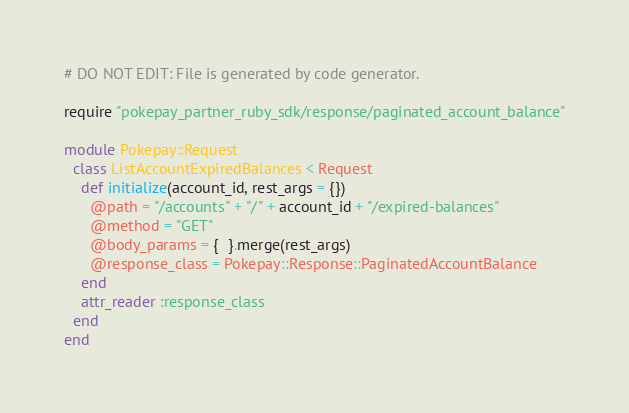<code> <loc_0><loc_0><loc_500><loc_500><_Ruby_># DO NOT EDIT: File is generated by code generator.

require "pokepay_partner_ruby_sdk/response/paginated_account_balance"

module Pokepay::Request
  class ListAccountExpiredBalances < Request
    def initialize(account_id, rest_args = {})
      @path = "/accounts" + "/" + account_id + "/expired-balances"
      @method = "GET"
      @body_params = {  }.merge(rest_args)
      @response_class = Pokepay::Response::PaginatedAccountBalance
    end
    attr_reader :response_class
  end
end
</code> 